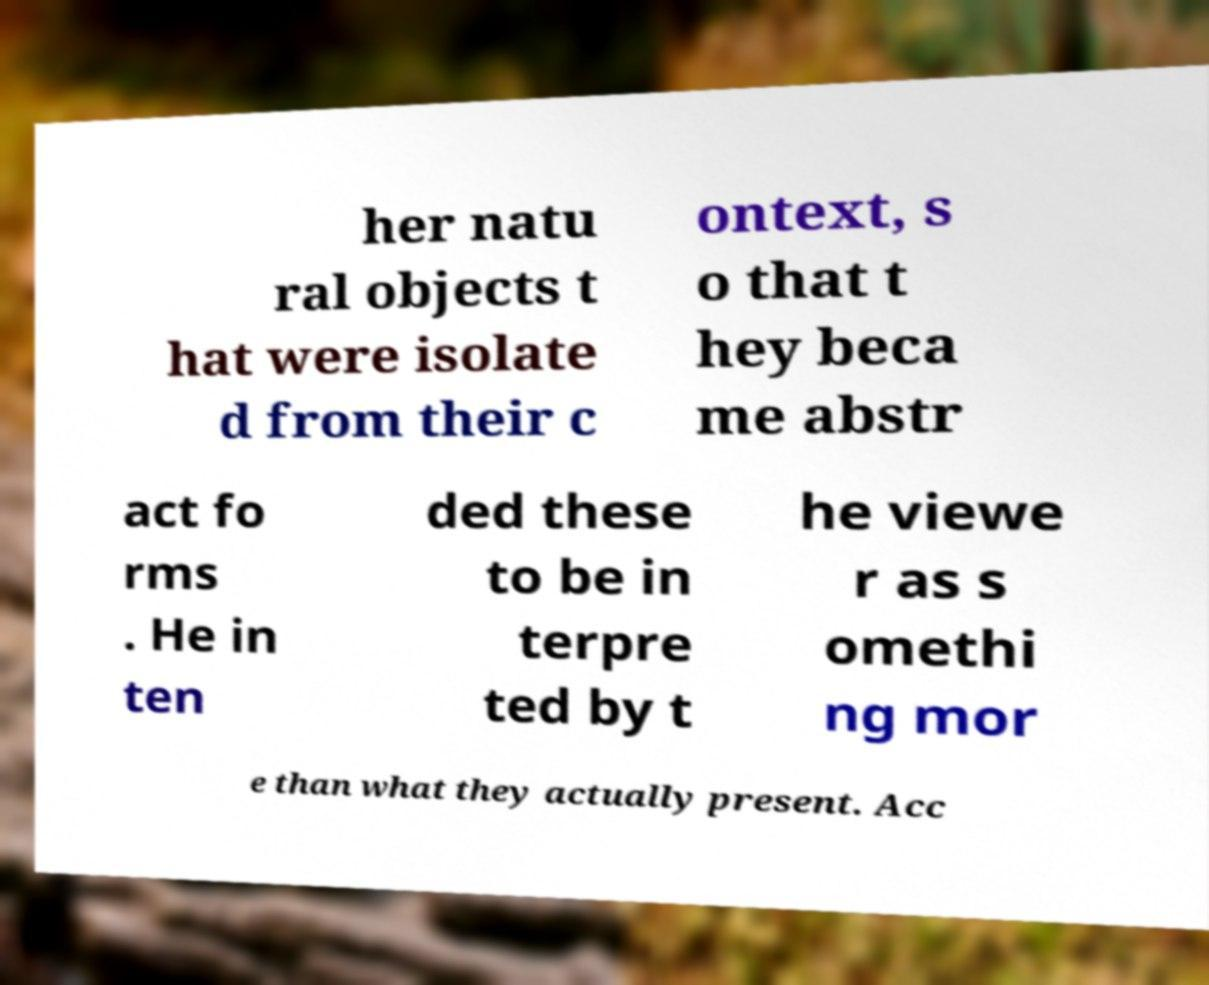Please read and relay the text visible in this image. What does it say? her natu ral objects t hat were isolate d from their c ontext, s o that t hey beca me abstr act fo rms . He in ten ded these to be in terpre ted by t he viewe r as s omethi ng mor e than what they actually present. Acc 